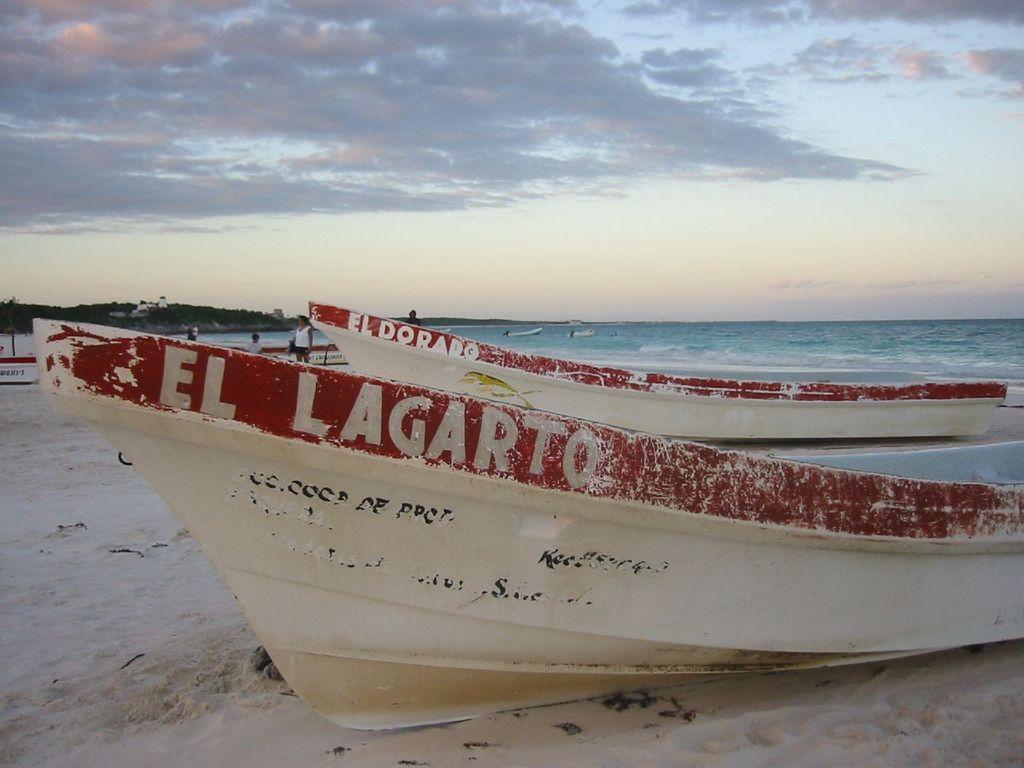Describe this image in one or two sentences. In this image we can see the sea, some sand, some boats with text, some people are standing, two boats in the water, some objects on the surface, one house on the mountain, one object in the water, some trees, bushes, plants and grass on the surface. At the top there is the cloudy sky. 